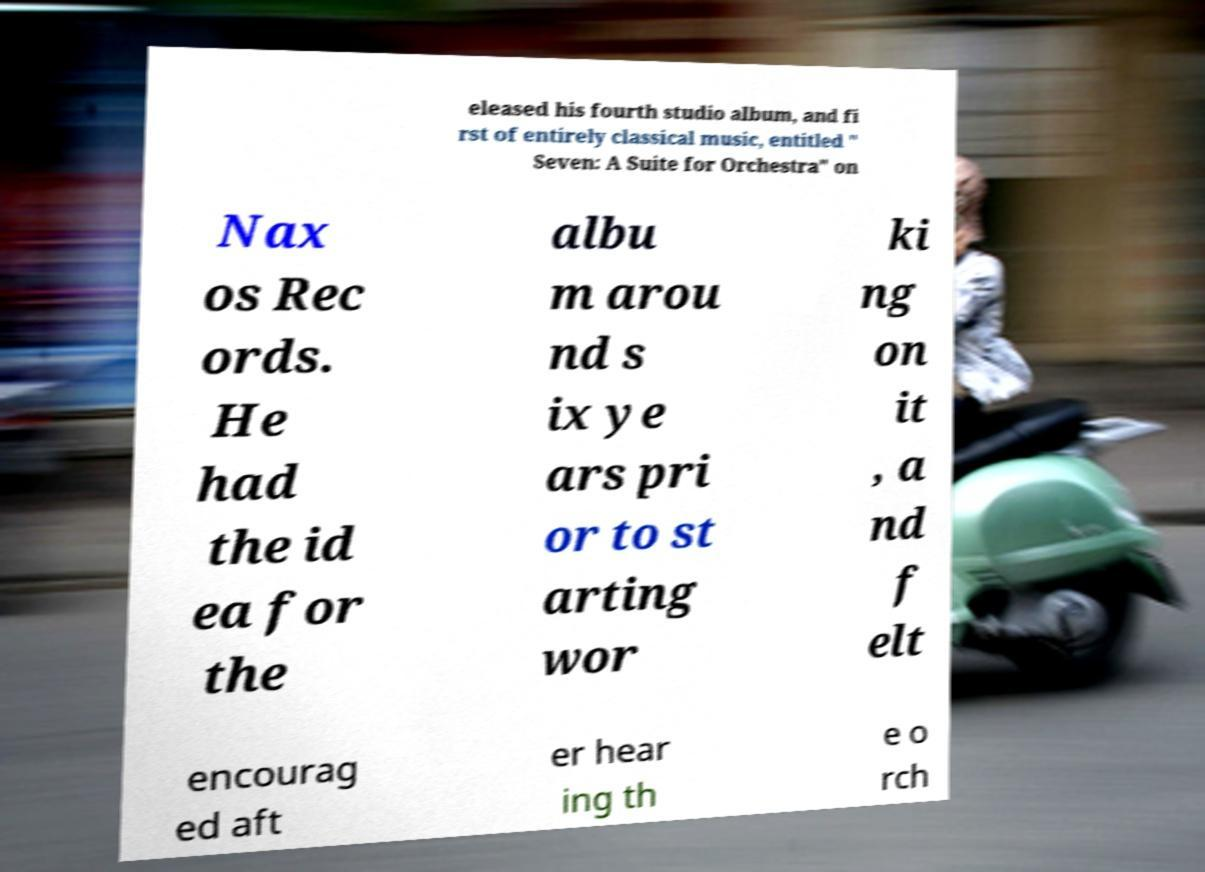What messages or text are displayed in this image? I need them in a readable, typed format. eleased his fourth studio album, and fi rst of entirely classical music, entitled " Seven: A Suite for Orchestra" on Nax os Rec ords. He had the id ea for the albu m arou nd s ix ye ars pri or to st arting wor ki ng on it , a nd f elt encourag ed aft er hear ing th e o rch 